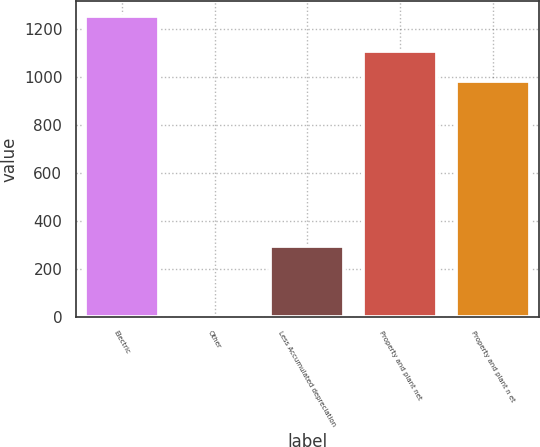<chart> <loc_0><loc_0><loc_500><loc_500><bar_chart><fcel>Electric<fcel>Other<fcel>Less Accumulated depreciation<fcel>Property and plant net<fcel>Property and plant n et<nl><fcel>1251<fcel>2<fcel>295<fcel>1104.9<fcel>980<nl></chart> 